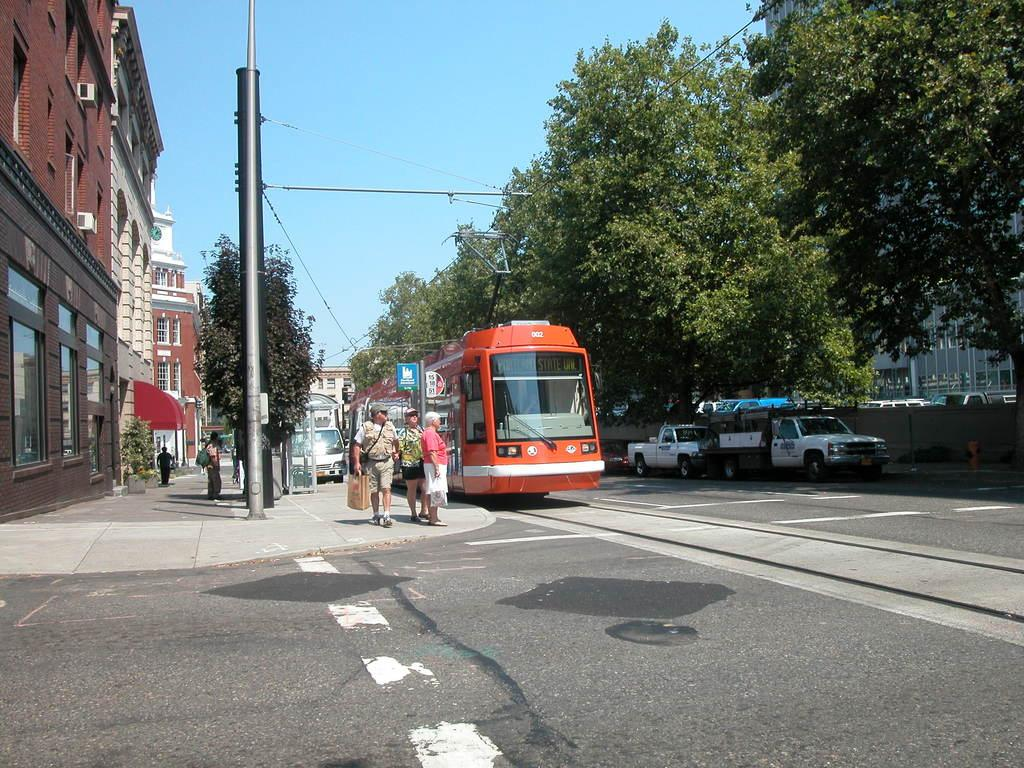What is the main subject of the picture? The main subject of the picture is a train. What else can be seen in the picture besides the train? There are buildings, trees, and people standing on a walkway in the picture. How many beginners are visible in the picture? There is no indication of anyone being a beginner in the image, as it features a train, buildings, trees, and people on a walkway. 